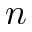<formula> <loc_0><loc_0><loc_500><loc_500>n</formula> 